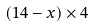<formula> <loc_0><loc_0><loc_500><loc_500>( 1 4 - x ) \times 4</formula> 